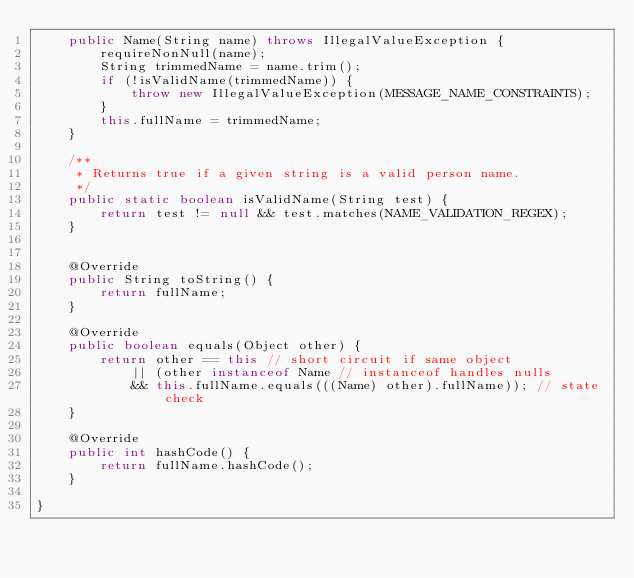Convert code to text. <code><loc_0><loc_0><loc_500><loc_500><_Java_>    public Name(String name) throws IllegalValueException {
        requireNonNull(name);
        String trimmedName = name.trim();
        if (!isValidName(trimmedName)) {
            throw new IllegalValueException(MESSAGE_NAME_CONSTRAINTS);
        }
        this.fullName = trimmedName;
    }

    /**
     * Returns true if a given string is a valid person name.
     */
    public static boolean isValidName(String test) {
        return test != null && test.matches(NAME_VALIDATION_REGEX);
    }


    @Override
    public String toString() {
        return fullName;
    }

    @Override
    public boolean equals(Object other) {
        return other == this // short circuit if same object
            || (other instanceof Name // instanceof handles nulls
            && this.fullName.equals(((Name) other).fullName)); // state check
    }

    @Override
    public int hashCode() {
        return fullName.hashCode();
    }

}
</code> 